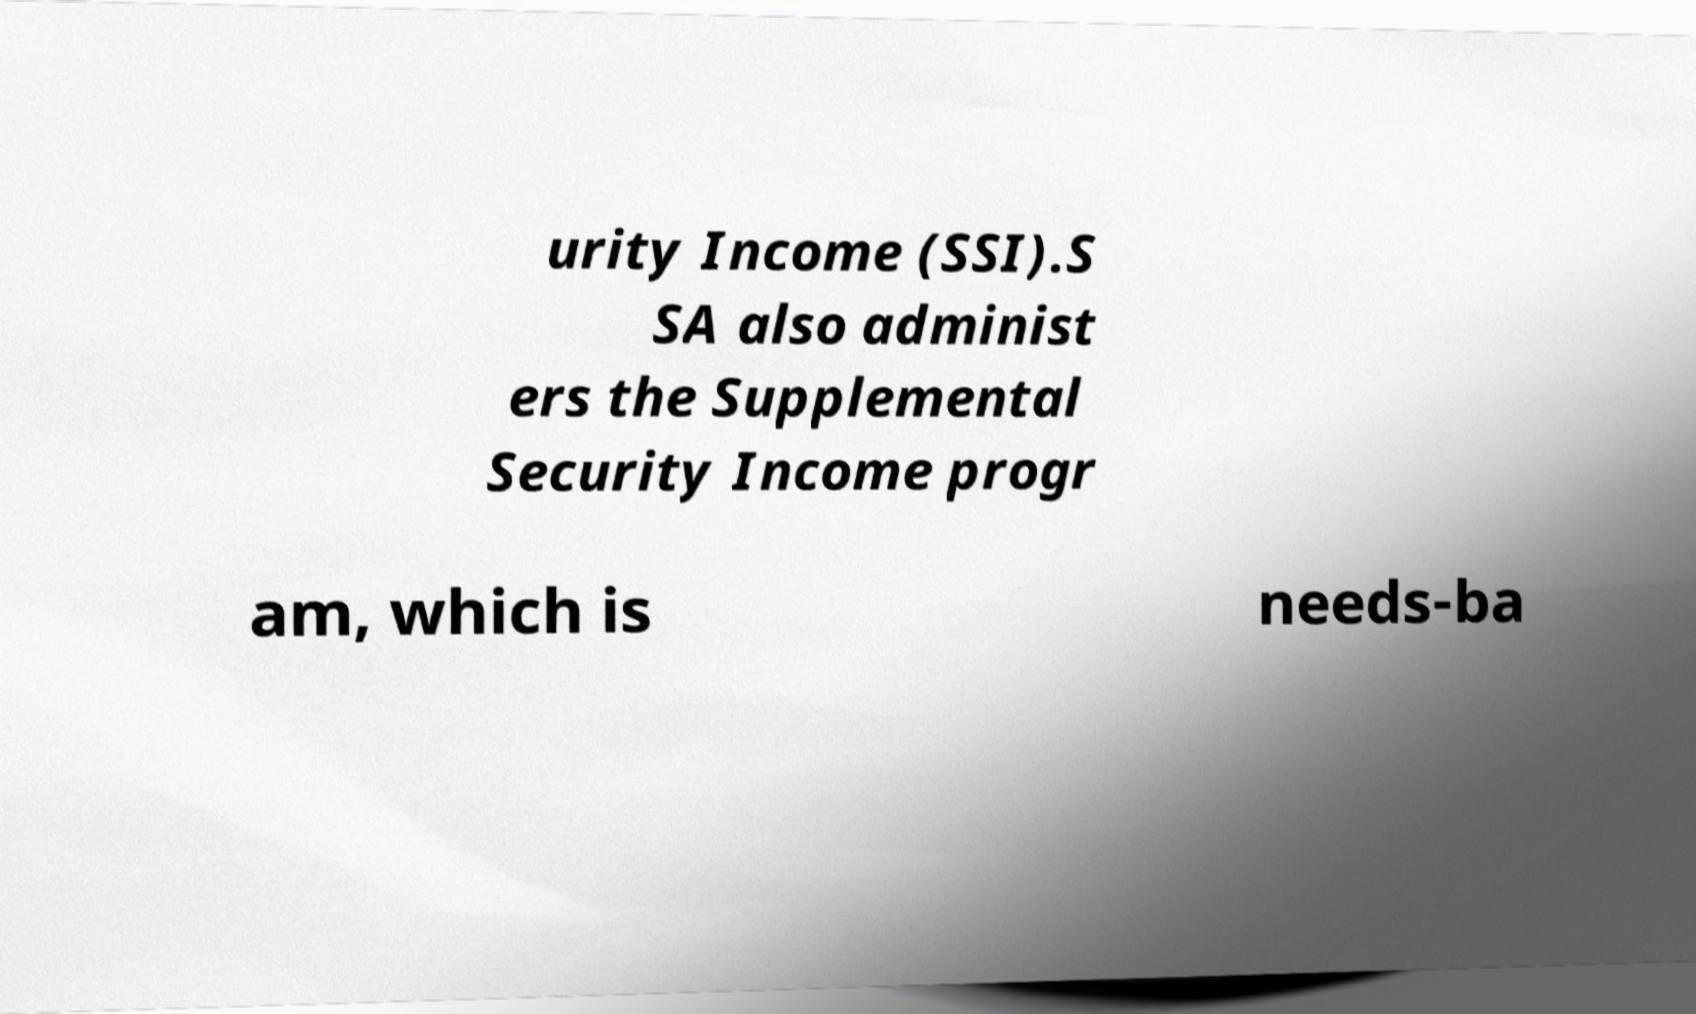What messages or text are displayed in this image? I need them in a readable, typed format. urity Income (SSI).S SA also administ ers the Supplemental Security Income progr am, which is needs-ba 